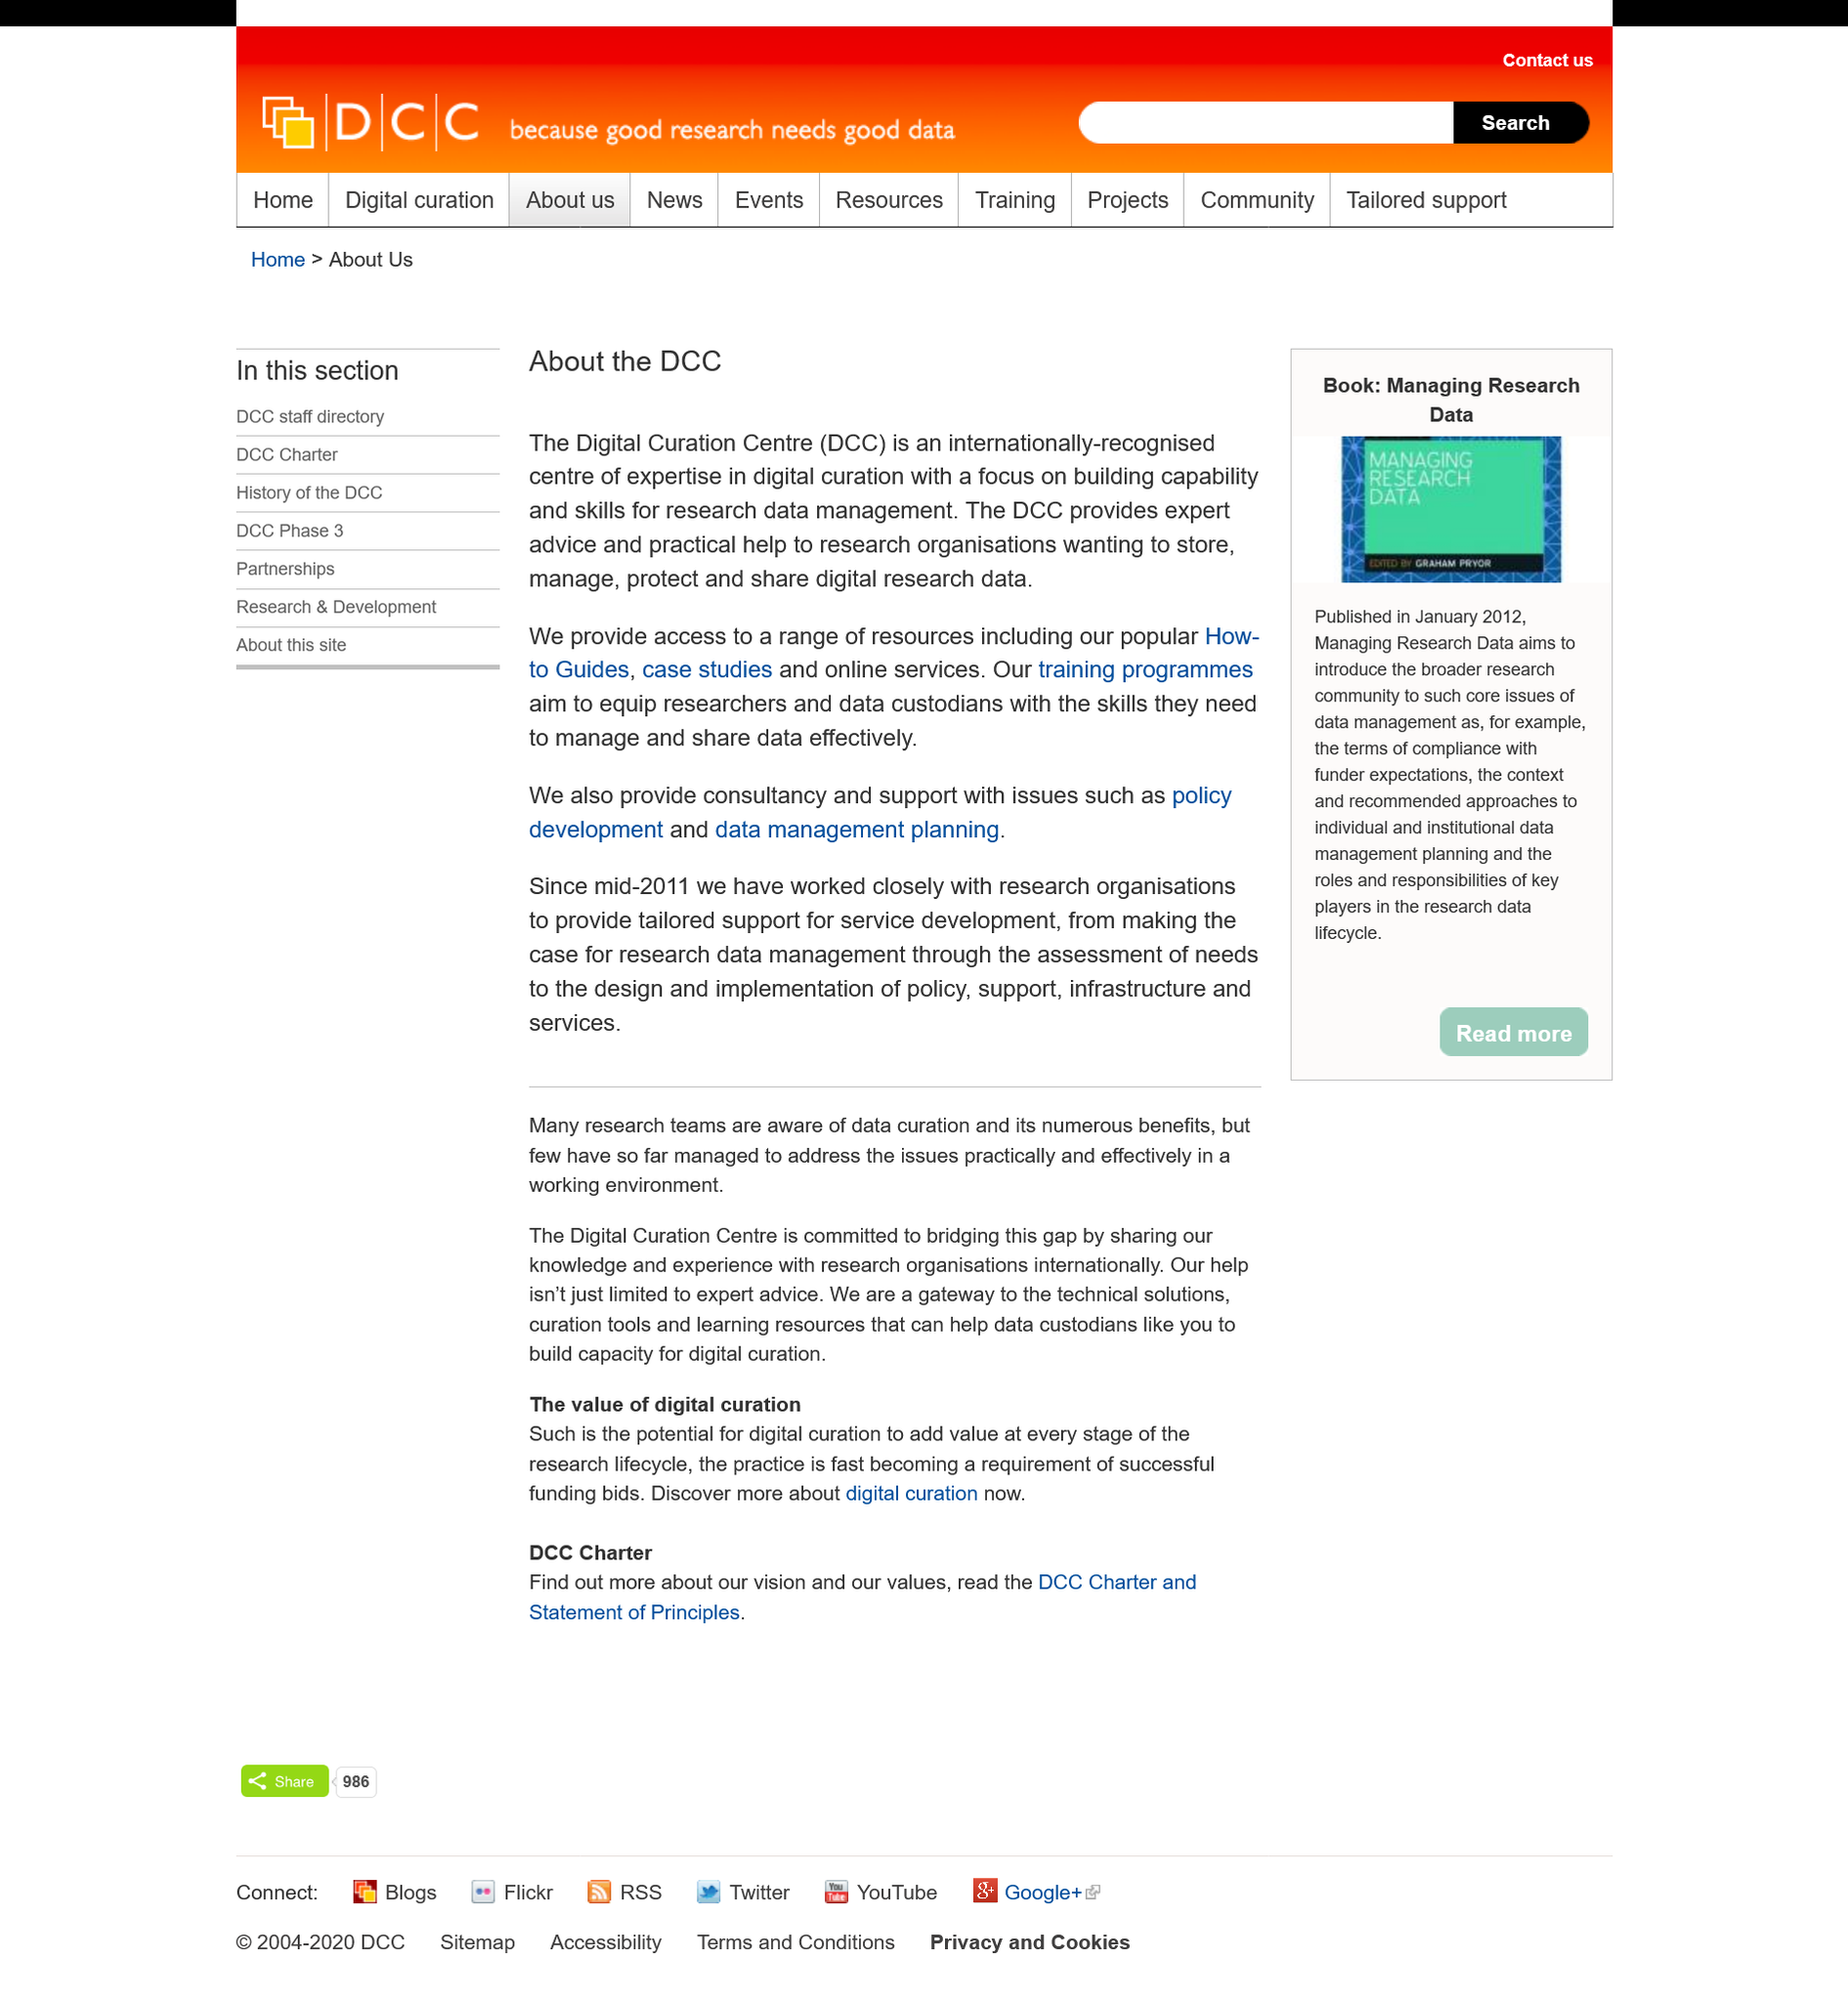Draw attention to some important aspects in this diagram. The DCC training programmes aim to develop the expertise of researchers and data custodians in managing and sharing data efficiently and effectively. The Digital Curation Centre, commonly referred to as the DCC, is also known by its alternate name. The Digital Curation Centre offers professional guidance and practical support to research institutions looking to effectively preserve, manage, safeguard, and distribute research data. 